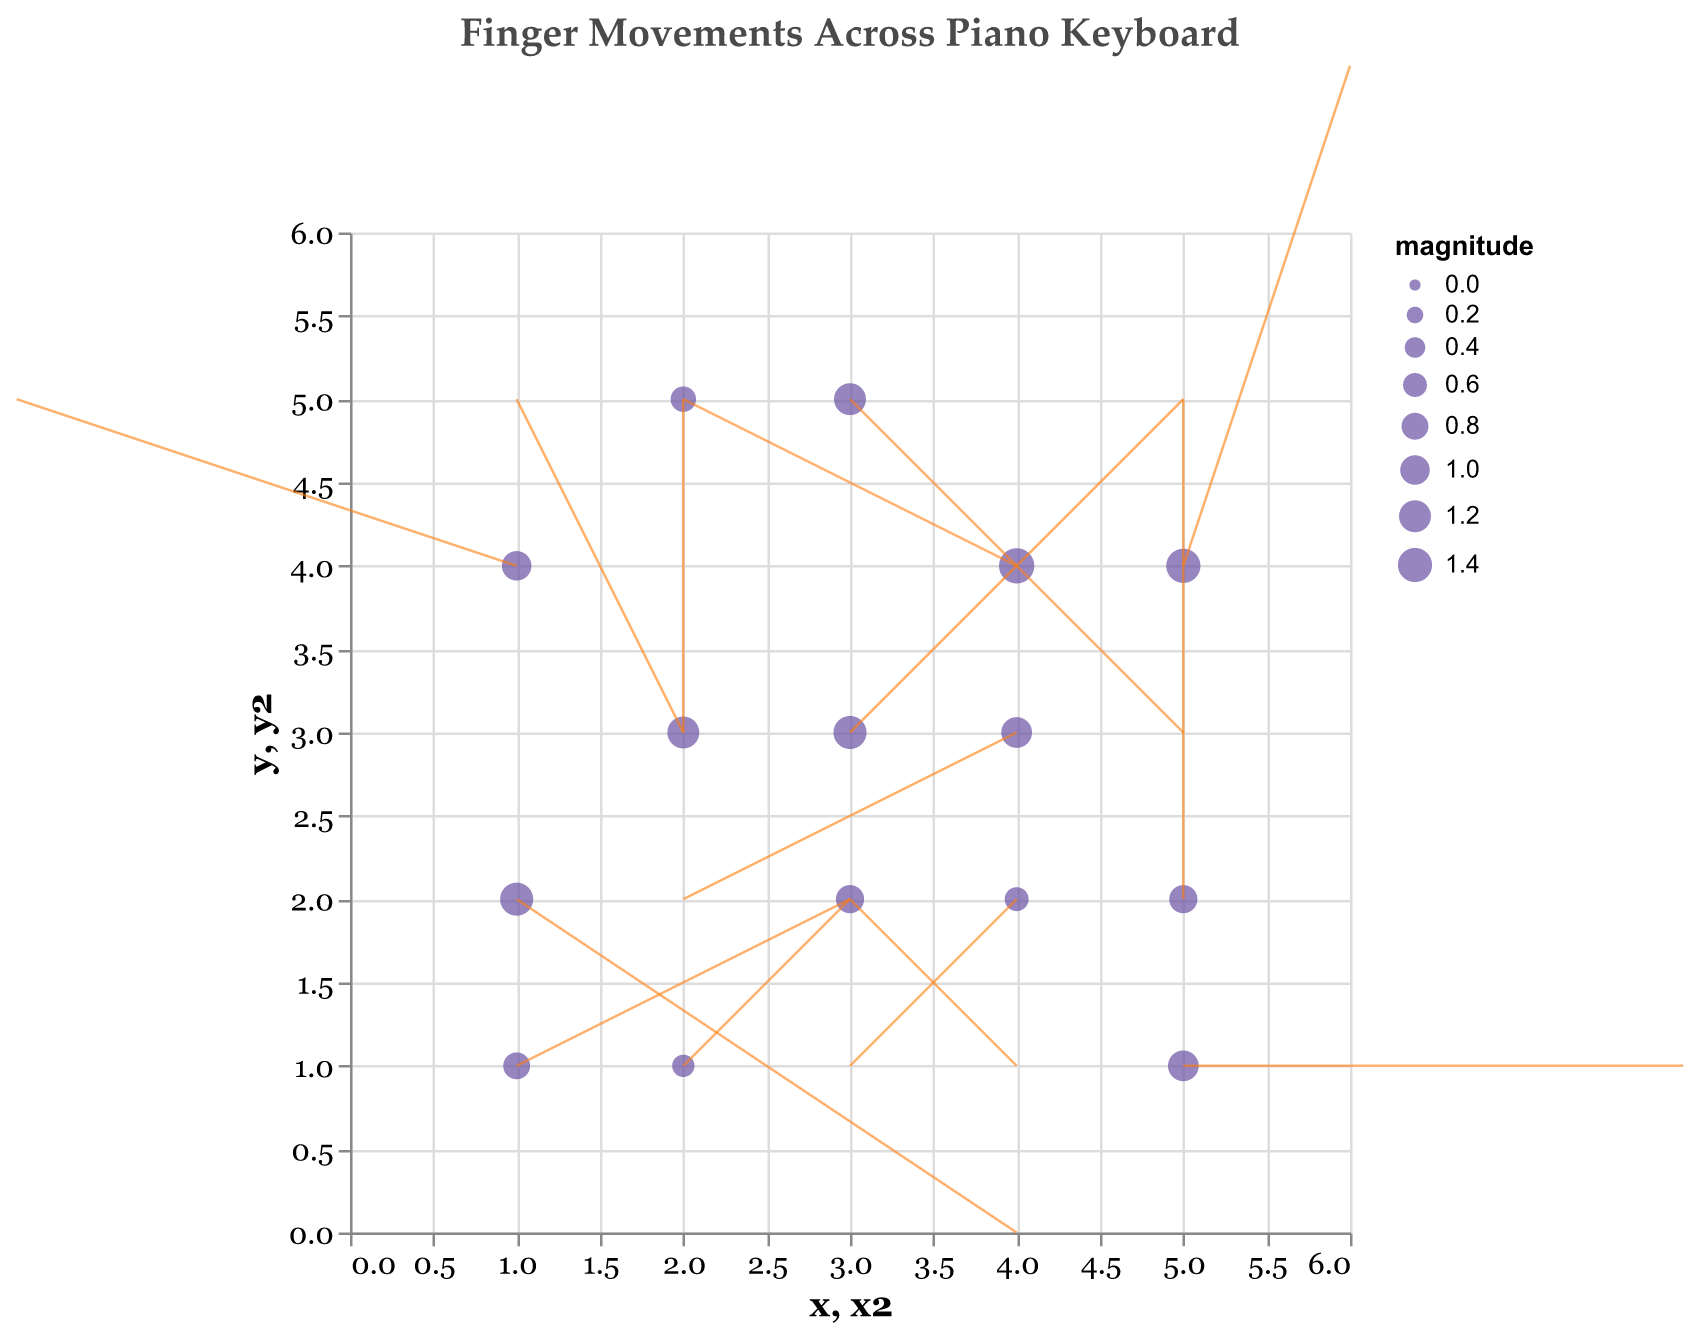What is the title of the figure? The title can be found at the top of the figure. It is generally a text that summarizes what the figure is about.
Answer: Finger Movements Across Piano Keyboard How many data points are visualized in the figure? The data points are represented by the points plotted on the figure. Count each point to determine the number of data points.
Answer: 15 Which direction does the movement at point (1,1) indicate? To find the direction of the movement at point (1,1), look at the arrow starting at this point. Check the values of 'u' and 'v' to determine the direction and length of the arrow.
Answer: Right and slightly up What is the magnitude of the movement at point (3,3)? The magnitude of a movement is represented by the size of the point. Refer to the corresponding value in the dataset. For point (3,3), the magnitude is shown in the dataset.
Answer: 1.3 Which data point has the largest magnitude of movement? To identify the largest magnitude, compare the sizes of all points in the figure. The largest point on the plot corresponds to the highest magnitude.
Answer: Point (4,4) What is the average magnitude of all data points? Sum all the magnitudes from the dataset and divide by the number of data points to calculate the average magnitude. The total magnitude is (0.8+1.2+0.9+1.5+1.1+0.7+1.3+0.6+1.4+1.0+1.2+0.9+0.5+1.1+1.3) = 15.5. Dividing by 15 gives the average.
Answer: 1.03 Compare the magnitude of movements at points (2,3) and (4,4) and state which is greater. Look at the 'magnitude' values corresponding to points (2,3) and (4,4). Compare these values directly.
Answer: 1.5 (point 4,4 is greater) What is the resultant movement vector at point (5,4)? The resultant movement vector combines the horizontal and vertical components (u and v). The vector at point (5,4) is given by (u=1, v=3).
Answer: (1, 3) What is the net vertical movement of the data points? Sum the vertical components (v) of all data points. The sum is (1 + 2 + -1 + 1 + 0 + -2 + 2 + -1 + 3 + 1 + -2 + 3 + 1 + -1 + -2) = 5
Answer: 5 Which data point has the largest vertical movement (v)? Examine the 'v' values of each data point in the dataset and identify the one with the largest absolute value. The largest 'v' value in the dataset is 3.
Answer: Points (5,4) and (5,2) Are there any data points with no horizontal movement (u = 0)? If so, which ones? Check the 'u' values in the dataset for any zero values. The points with u=0 are (2,5) and (5,2).
Answer: Points (2,5) and (5,2) 